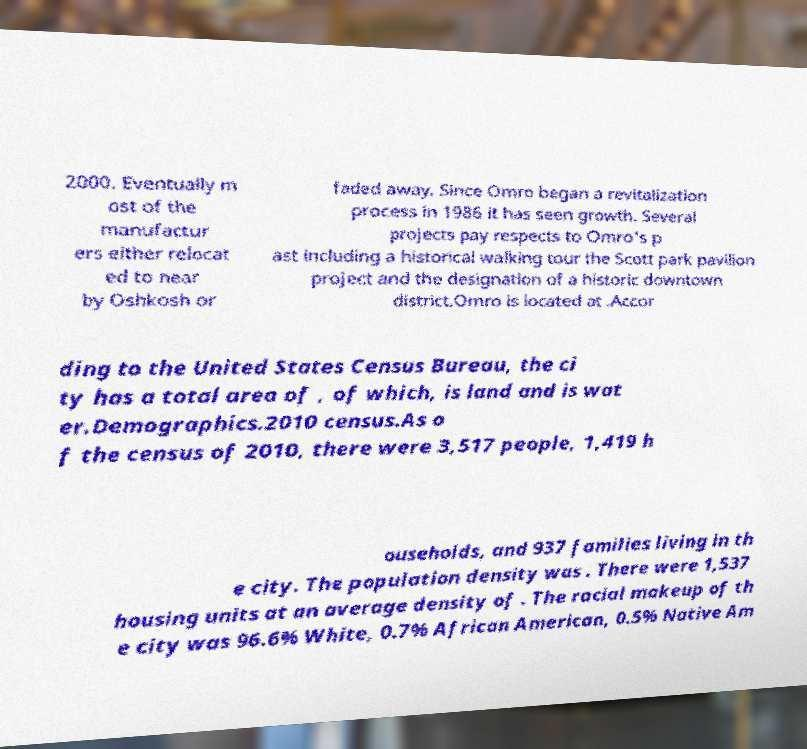Please identify and transcribe the text found in this image. 2000. Eventually m ost of the manufactur ers either relocat ed to near by Oshkosh or faded away. Since Omro began a revitalization process in 1986 it has seen growth. Several projects pay respects to Omro's p ast including a historical walking tour the Scott park pavilion project and the designation of a historic downtown district.Omro is located at .Accor ding to the United States Census Bureau, the ci ty has a total area of , of which, is land and is wat er.Demographics.2010 census.As o f the census of 2010, there were 3,517 people, 1,419 h ouseholds, and 937 families living in th e city. The population density was . There were 1,537 housing units at an average density of . The racial makeup of th e city was 96.6% White, 0.7% African American, 0.5% Native Am 